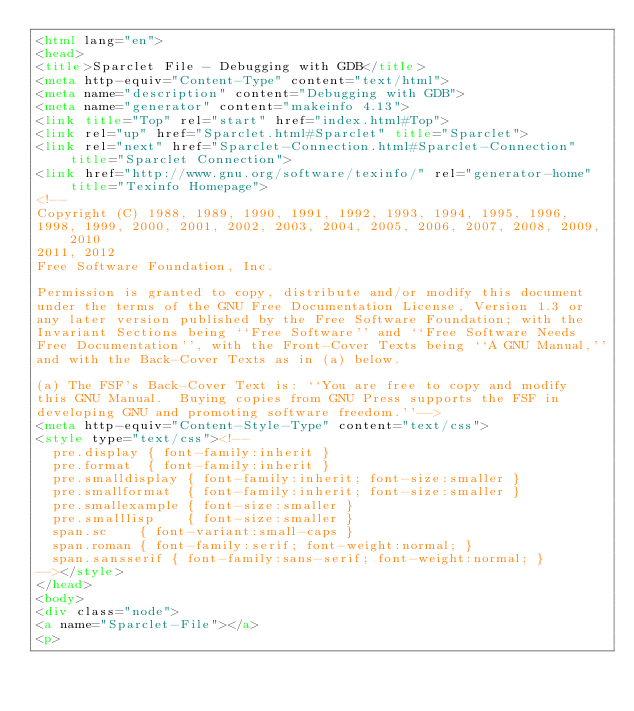Convert code to text. <code><loc_0><loc_0><loc_500><loc_500><_HTML_><html lang="en">
<head>
<title>Sparclet File - Debugging with GDB</title>
<meta http-equiv="Content-Type" content="text/html">
<meta name="description" content="Debugging with GDB">
<meta name="generator" content="makeinfo 4.13">
<link title="Top" rel="start" href="index.html#Top">
<link rel="up" href="Sparclet.html#Sparclet" title="Sparclet">
<link rel="next" href="Sparclet-Connection.html#Sparclet-Connection" title="Sparclet Connection">
<link href="http://www.gnu.org/software/texinfo/" rel="generator-home" title="Texinfo Homepage">
<!--
Copyright (C) 1988, 1989, 1990, 1991, 1992, 1993, 1994, 1995, 1996,
1998, 1999, 2000, 2001, 2002, 2003, 2004, 2005, 2006, 2007, 2008, 2009, 2010
2011, 2012
Free Software Foundation, Inc.

Permission is granted to copy, distribute and/or modify this document
under the terms of the GNU Free Documentation License, Version 1.3 or
any later version published by the Free Software Foundation; with the
Invariant Sections being ``Free Software'' and ``Free Software Needs
Free Documentation'', with the Front-Cover Texts being ``A GNU Manual,''
and with the Back-Cover Texts as in (a) below.

(a) The FSF's Back-Cover Text is: ``You are free to copy and modify
this GNU Manual.  Buying copies from GNU Press supports the FSF in
developing GNU and promoting software freedom.''-->
<meta http-equiv="Content-Style-Type" content="text/css">
<style type="text/css"><!--
  pre.display { font-family:inherit }
  pre.format  { font-family:inherit }
  pre.smalldisplay { font-family:inherit; font-size:smaller }
  pre.smallformat  { font-family:inherit; font-size:smaller }
  pre.smallexample { font-size:smaller }
  pre.smalllisp    { font-size:smaller }
  span.sc    { font-variant:small-caps }
  span.roman { font-family:serif; font-weight:normal; } 
  span.sansserif { font-family:sans-serif; font-weight:normal; } 
--></style>
</head>
<body>
<div class="node">
<a name="Sparclet-File"></a>
<p></code> 